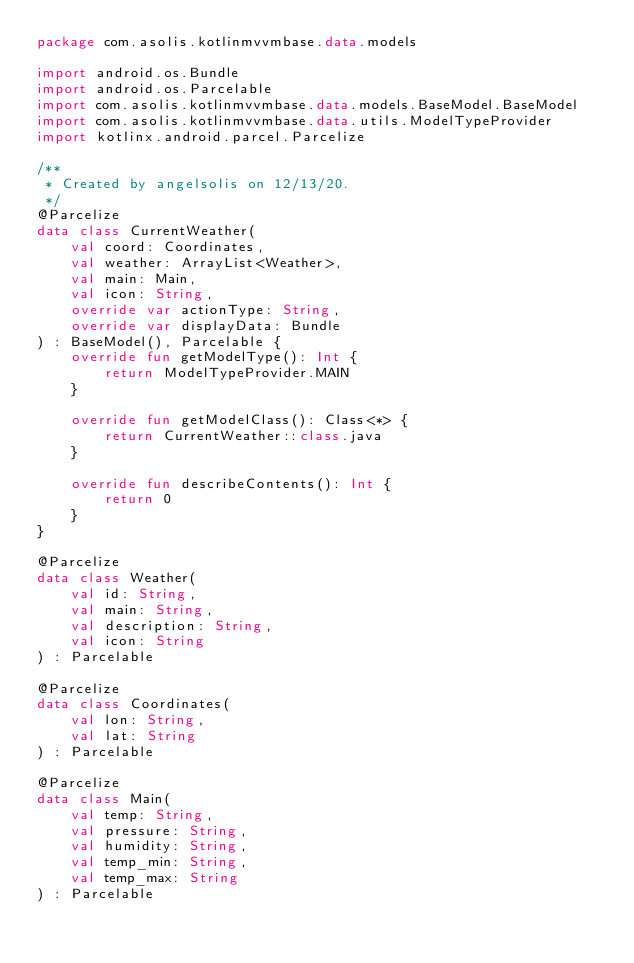Convert code to text. <code><loc_0><loc_0><loc_500><loc_500><_Kotlin_>package com.asolis.kotlinmvvmbase.data.models

import android.os.Bundle
import android.os.Parcelable
import com.asolis.kotlinmvvmbase.data.models.BaseModel.BaseModel
import com.asolis.kotlinmvvmbase.data.utils.ModelTypeProvider
import kotlinx.android.parcel.Parcelize

/**
 * Created by angelsolis on 12/13/20.
 */
@Parcelize
data class CurrentWeather(
    val coord: Coordinates,
    val weather: ArrayList<Weather>,
    val main: Main,
    val icon: String, 
    override var actionType: String, 
    override var displayData: Bundle
) : BaseModel(), Parcelable {
    override fun getModelType(): Int {
        return ModelTypeProvider.MAIN
    }

    override fun getModelClass(): Class<*> {
        return CurrentWeather::class.java
    }

    override fun describeContents(): Int {
        return 0
    }
}

@Parcelize
data class Weather(
    val id: String,
    val main: String,
    val description: String,
    val icon: String
) : Parcelable

@Parcelize
data class Coordinates(
    val lon: String,
    val lat: String
) : Parcelable

@Parcelize
data class Main(
    val temp: String,
    val pressure: String,
    val humidity: String,
    val temp_min: String,
    val temp_max: String
) : Parcelable

</code> 